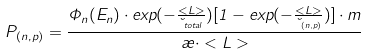<formula> <loc_0><loc_0><loc_500><loc_500>P _ { ( n , p ) } = \frac { \Phi _ { n } ( E _ { n } ) \cdot e x p ( - \frac { < L > } { \lambda _ { t o t a l } } ) [ 1 - e x p ( - \frac { < L > } { \lambda _ { ( n , p ) } } ) ] \cdot m } { \rho \cdot < L > }</formula> 